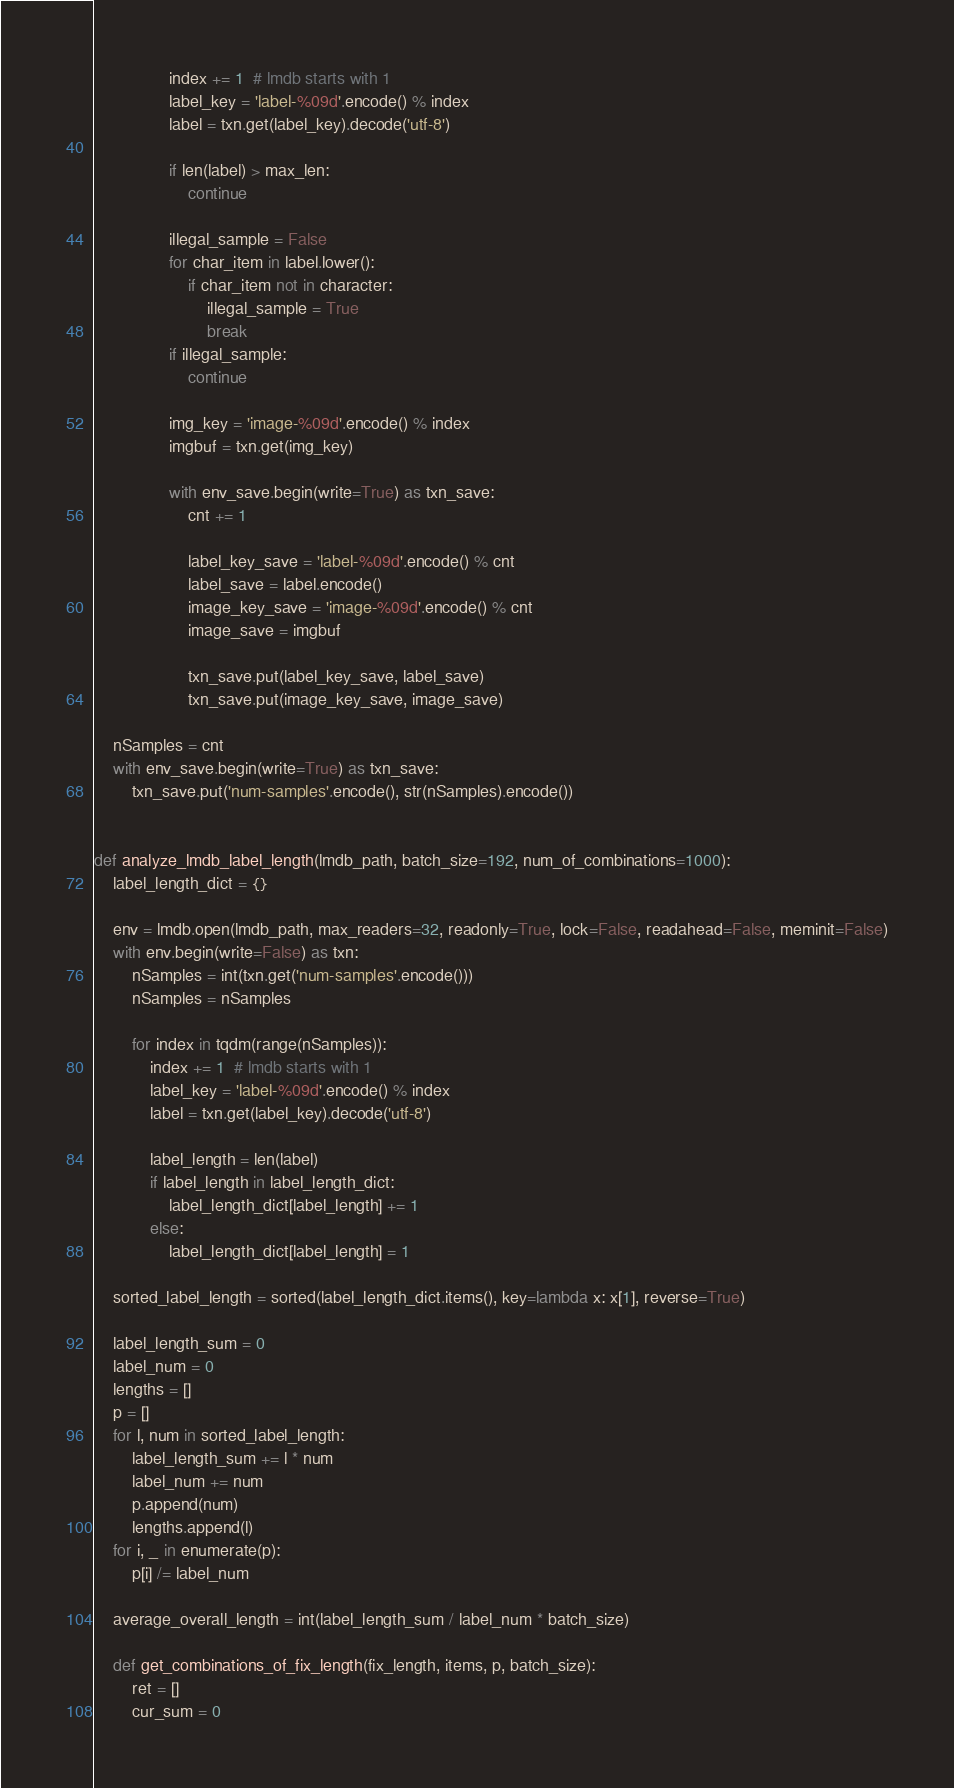<code> <loc_0><loc_0><loc_500><loc_500><_Python_>                index += 1  # lmdb starts with 1
                label_key = 'label-%09d'.encode() % index
                label = txn.get(label_key).decode('utf-8')

                if len(label) > max_len:
                    continue

                illegal_sample = False
                for char_item in label.lower():
                    if char_item not in character:
                        illegal_sample = True
                        break
                if illegal_sample:
                    continue

                img_key = 'image-%09d'.encode() % index
                imgbuf = txn.get(img_key)

                with env_save.begin(write=True) as txn_save:
                    cnt += 1

                    label_key_save = 'label-%09d'.encode() % cnt
                    label_save = label.encode()
                    image_key_save = 'image-%09d'.encode() % cnt
                    image_save = imgbuf

                    txn_save.put(label_key_save, label_save)
                    txn_save.put(image_key_save, image_save)

    nSamples = cnt
    with env_save.begin(write=True) as txn_save:
        txn_save.put('num-samples'.encode(), str(nSamples).encode())


def analyze_lmdb_label_length(lmdb_path, batch_size=192, num_of_combinations=1000):
    label_length_dict = {}

    env = lmdb.open(lmdb_path, max_readers=32, readonly=True, lock=False, readahead=False, meminit=False)
    with env.begin(write=False) as txn:
        nSamples = int(txn.get('num-samples'.encode()))
        nSamples = nSamples

        for index in tqdm(range(nSamples)):
            index += 1  # lmdb starts with 1
            label_key = 'label-%09d'.encode() % index
            label = txn.get(label_key).decode('utf-8')

            label_length = len(label)
            if label_length in label_length_dict:
                label_length_dict[label_length] += 1
            else:
                label_length_dict[label_length] = 1

    sorted_label_length = sorted(label_length_dict.items(), key=lambda x: x[1], reverse=True)

    label_length_sum = 0
    label_num = 0
    lengths = []
    p = []
    for l, num in sorted_label_length:
        label_length_sum += l * num
        label_num += num
        p.append(num)
        lengths.append(l)
    for i, _ in enumerate(p):
        p[i] /= label_num

    average_overall_length = int(label_length_sum / label_num * batch_size)

    def get_combinations_of_fix_length(fix_length, items, p, batch_size):
        ret = []
        cur_sum = 0</code> 